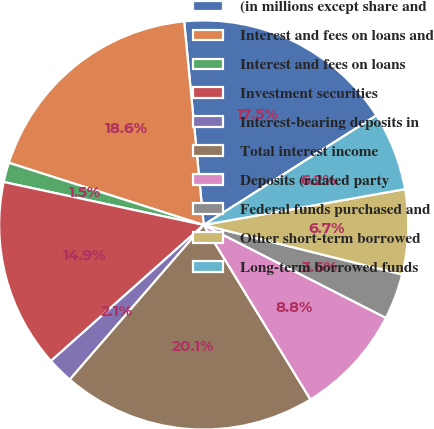<chart> <loc_0><loc_0><loc_500><loc_500><pie_chart><fcel>(in millions except share and<fcel>Interest and fees on loans and<fcel>Interest and fees on loans<fcel>Investment securities<fcel>Interest-bearing deposits in<fcel>Total interest income<fcel>Deposits (related party<fcel>Federal funds purchased and<fcel>Other short-term borrowed<fcel>Long-term borrowed funds<nl><fcel>17.53%<fcel>18.56%<fcel>1.55%<fcel>14.95%<fcel>2.06%<fcel>20.1%<fcel>8.76%<fcel>3.61%<fcel>6.7%<fcel>6.19%<nl></chart> 